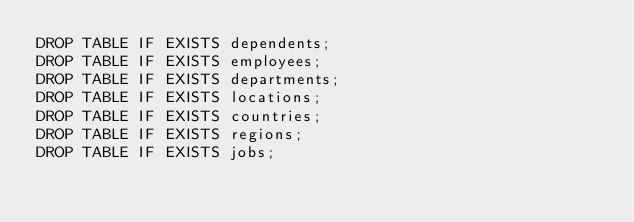<code> <loc_0><loc_0><loc_500><loc_500><_SQL_>DROP TABLE IF EXISTS dependents;
DROP TABLE IF EXISTS employees;
DROP TABLE IF EXISTS departments;
DROP TABLE IF EXISTS locations;
DROP TABLE IF EXISTS countries;
DROP TABLE IF EXISTS regions;
DROP TABLE IF EXISTS jobs;</code> 